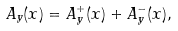<formula> <loc_0><loc_0><loc_500><loc_500>A _ { y } ( x ) = A _ { y } ^ { + } ( x ) + A _ { y } ^ { - } ( x ) ,</formula> 